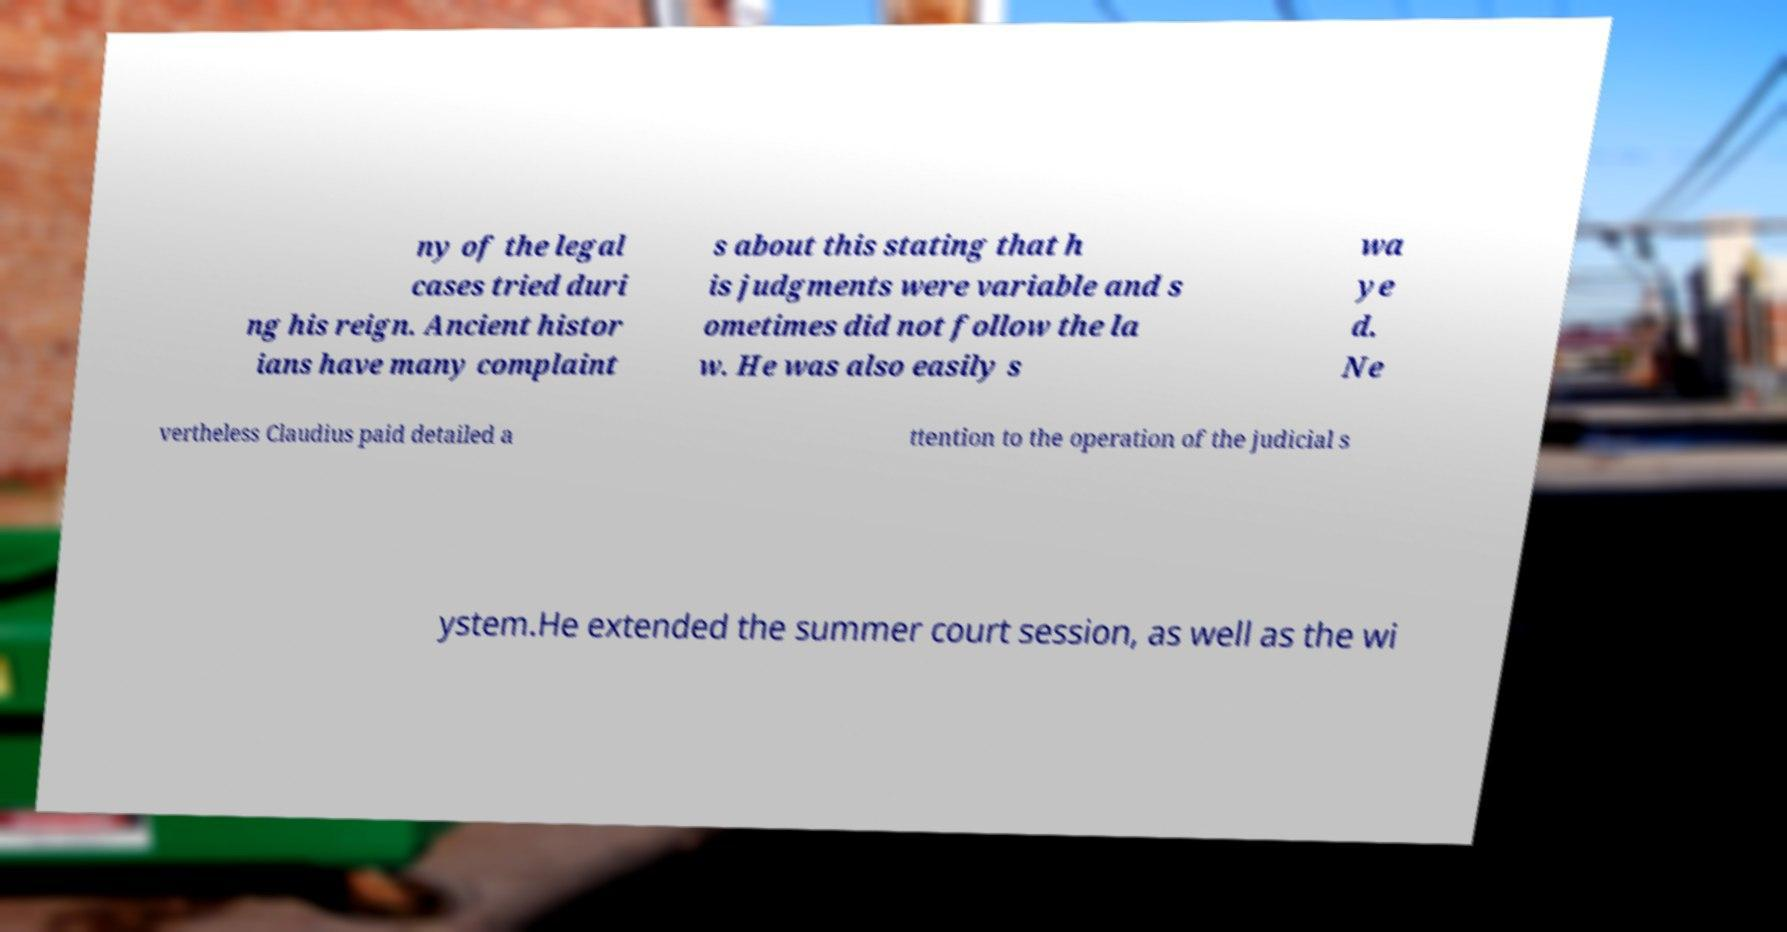Could you assist in decoding the text presented in this image and type it out clearly? ny of the legal cases tried duri ng his reign. Ancient histor ians have many complaint s about this stating that h is judgments were variable and s ometimes did not follow the la w. He was also easily s wa ye d. Ne vertheless Claudius paid detailed a ttention to the operation of the judicial s ystem.He extended the summer court session, as well as the wi 